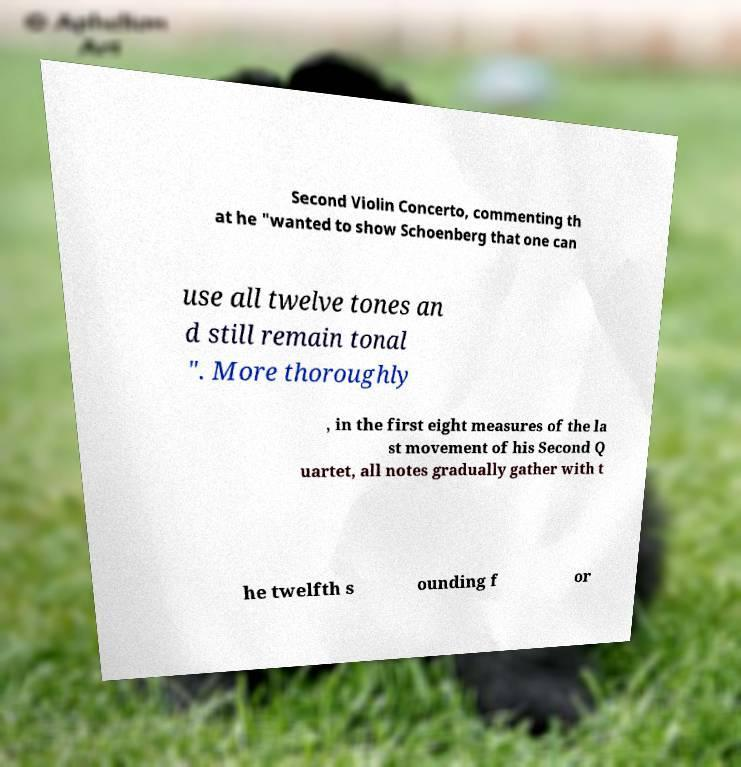Can you read and provide the text displayed in the image?This photo seems to have some interesting text. Can you extract and type it out for me? Second Violin Concerto, commenting th at he "wanted to show Schoenberg that one can use all twelve tones an d still remain tonal ". More thoroughly , in the first eight measures of the la st movement of his Second Q uartet, all notes gradually gather with t he twelfth s ounding f or 